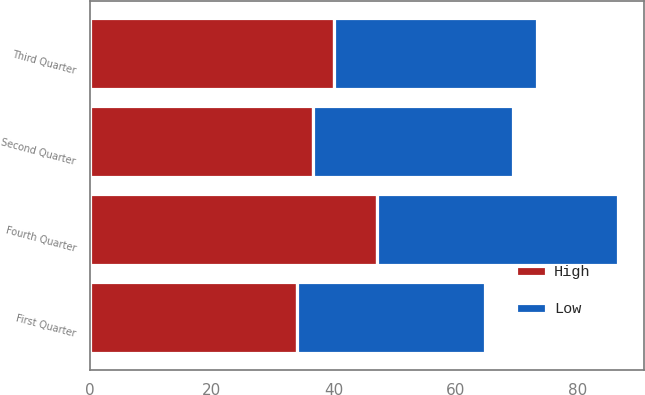Convert chart to OTSL. <chart><loc_0><loc_0><loc_500><loc_500><stacked_bar_chart><ecel><fcel>First Quarter<fcel>Second Quarter<fcel>Third Quarter<fcel>Fourth Quarter<nl><fcel>High<fcel>34.06<fcel>36.63<fcel>40.11<fcel>47.16<nl><fcel>Low<fcel>30.75<fcel>32.8<fcel>33.28<fcel>39.49<nl></chart> 